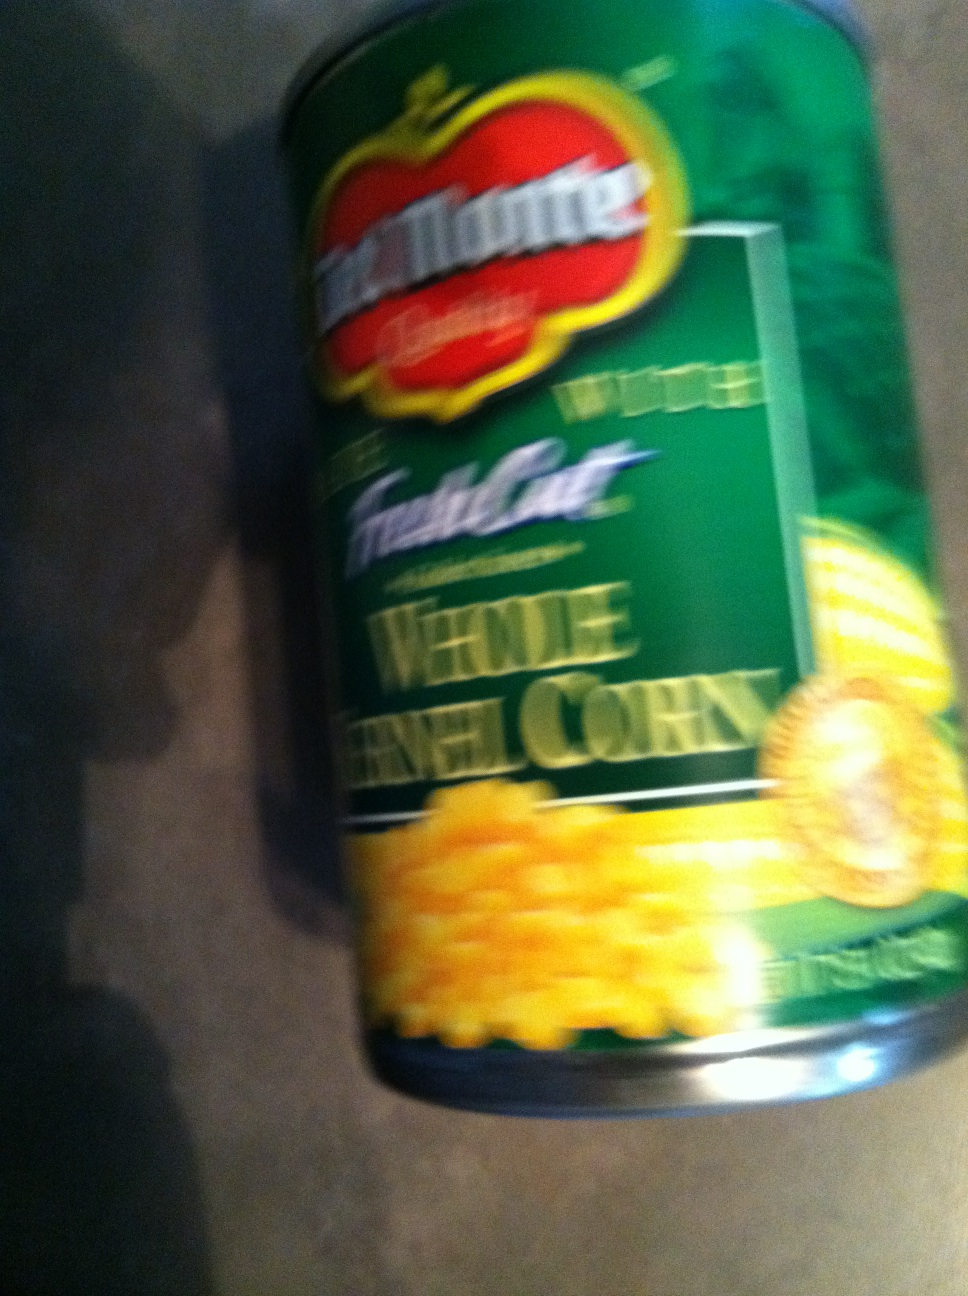Can you tell me about a recipe that uses whole kernel corn? Certainly! A popular recipe using whole kernel corn is Corn Chowder. It's a creamy, comforting soup typically made with corn, potatoes, onions, and sometimes bacon or ham for extra flavor. How do I make Corn Chowder? To make Corn Chowder, sauté onions (and optional bacon or diced ham) until tender. Add diced potatoes, corn, and enough chicken or vegetable broth to cover. Season with salt and pepper. Simmer until the potatoes are tender. Add cream or milk for richness, warm through, and serve hot. Enjoy your homemade corn chowder! 